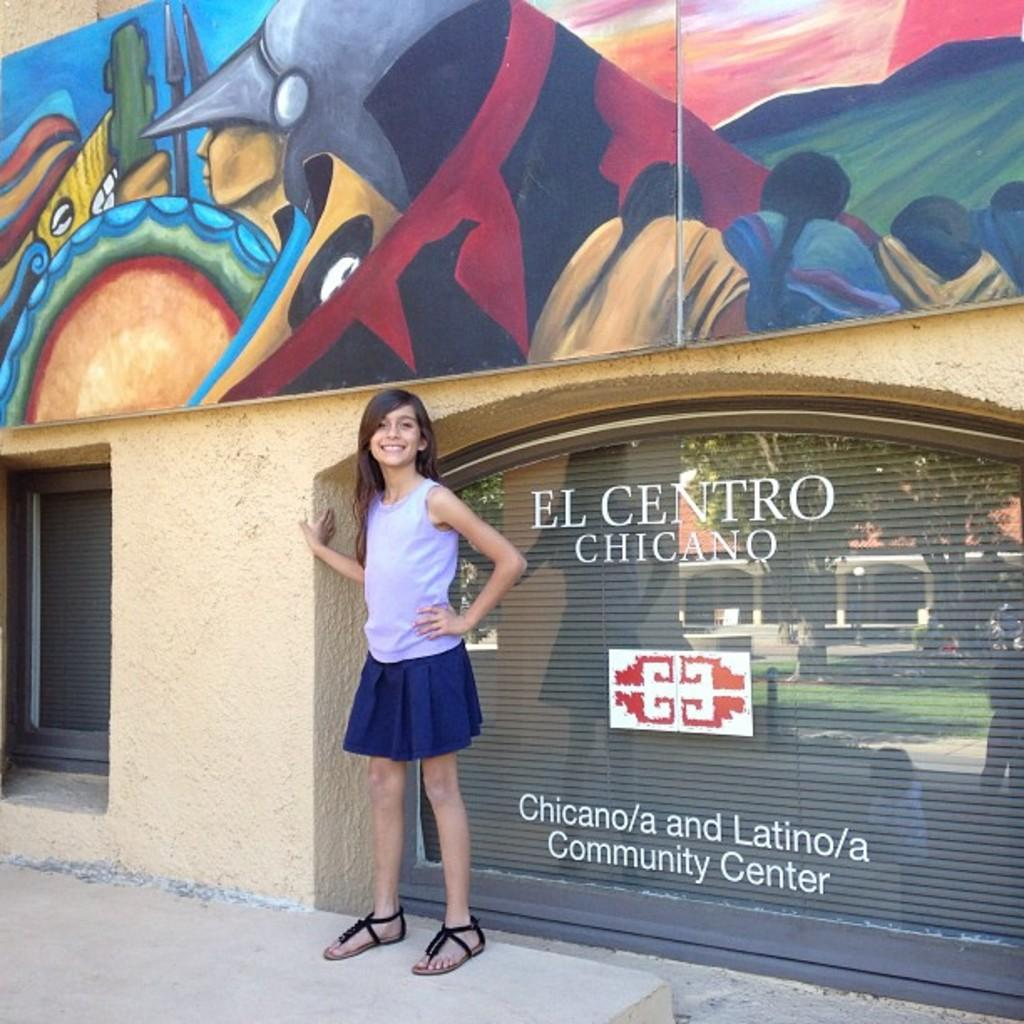<image>
Describe the image concisely. A young girl stands in front of a building with El Centro Chicano on the front of a window. 